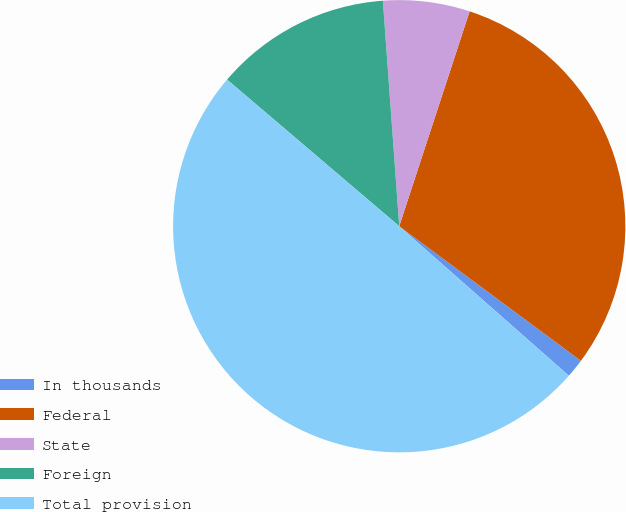Convert chart to OTSL. <chart><loc_0><loc_0><loc_500><loc_500><pie_chart><fcel>In thousands<fcel>Federal<fcel>State<fcel>Foreign<fcel>Total provision<nl><fcel>1.35%<fcel>30.11%<fcel>6.19%<fcel>12.62%<fcel>49.73%<nl></chart> 